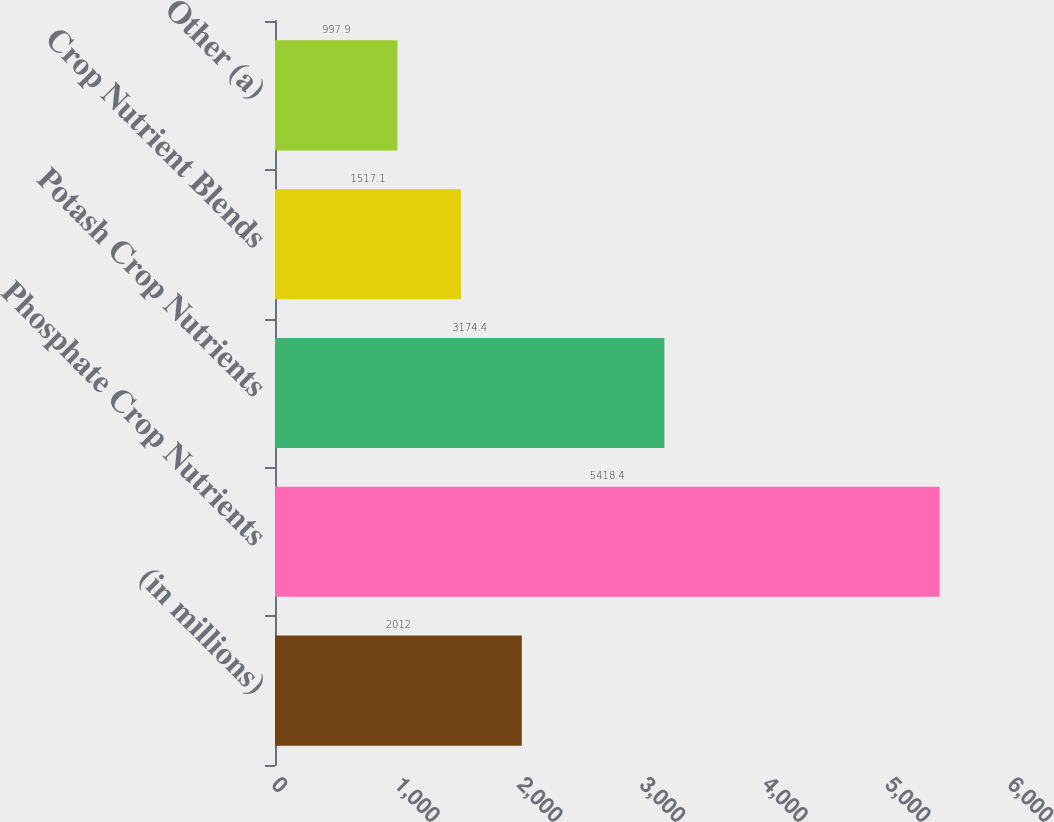<chart> <loc_0><loc_0><loc_500><loc_500><bar_chart><fcel>(in millions)<fcel>Phosphate Crop Nutrients<fcel>Potash Crop Nutrients<fcel>Crop Nutrient Blends<fcel>Other (a)<nl><fcel>2012<fcel>5418.4<fcel>3174.4<fcel>1517.1<fcel>997.9<nl></chart> 